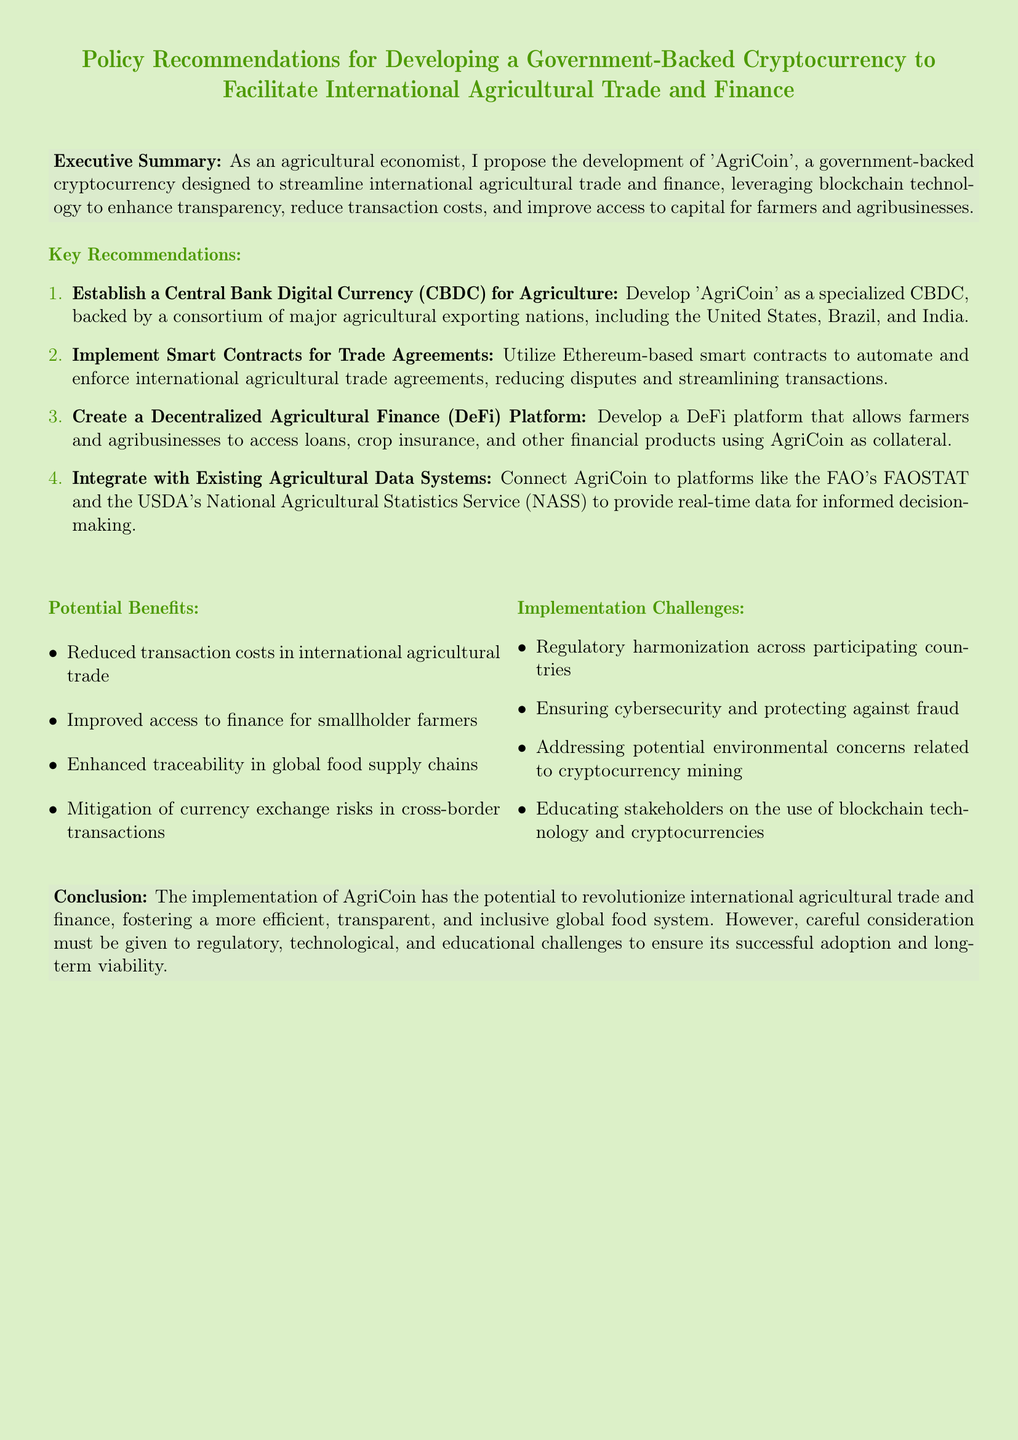What is the proposed name for the government-backed cryptocurrency? The document states that the proposed name for the cryptocurrency is 'AgriCoin'.
Answer: AgriCoin Which countries are mentioned as part of the consortium for AgriCoin? The document mentions the United States, Brazil, and India as major agricultural exporting nations in the consortium.
Answer: United States, Brazil, India What technology is suggested for automating trade agreements? The document recommends utilizing Ethereum-based smart contracts to automate trade agreements.
Answer: Ethereum-based smart contracts List one potential benefit mentioned for using AgriCoin. The document lists several benefits, one of which is improved access to finance for smallholder farmers.
Answer: Improved access to finance for smallholder farmers What is one implementation challenge highlighted in the document? The document identifies regulatory harmonization across participating countries as a key challenge.
Answer: Regulatory harmonization What type of platform is suggested for accessing financial products? The document recommends developing a Decentralized Agricultural Finance (DeFi) platform for accessing loan products.
Answer: Decentralized Agricultural Finance (DeFi) platform In which section is the Executive Summary found? The Executive Summary is presented right after the title of the document and prior to key recommendations.
Answer: After the title What is the conclusion about the potential of AgriCoin? The document concludes that AgriCoin could revolutionize international agricultural trade and finance, leading to a more efficient system.
Answer: Revolutionize international agricultural trade and finance 